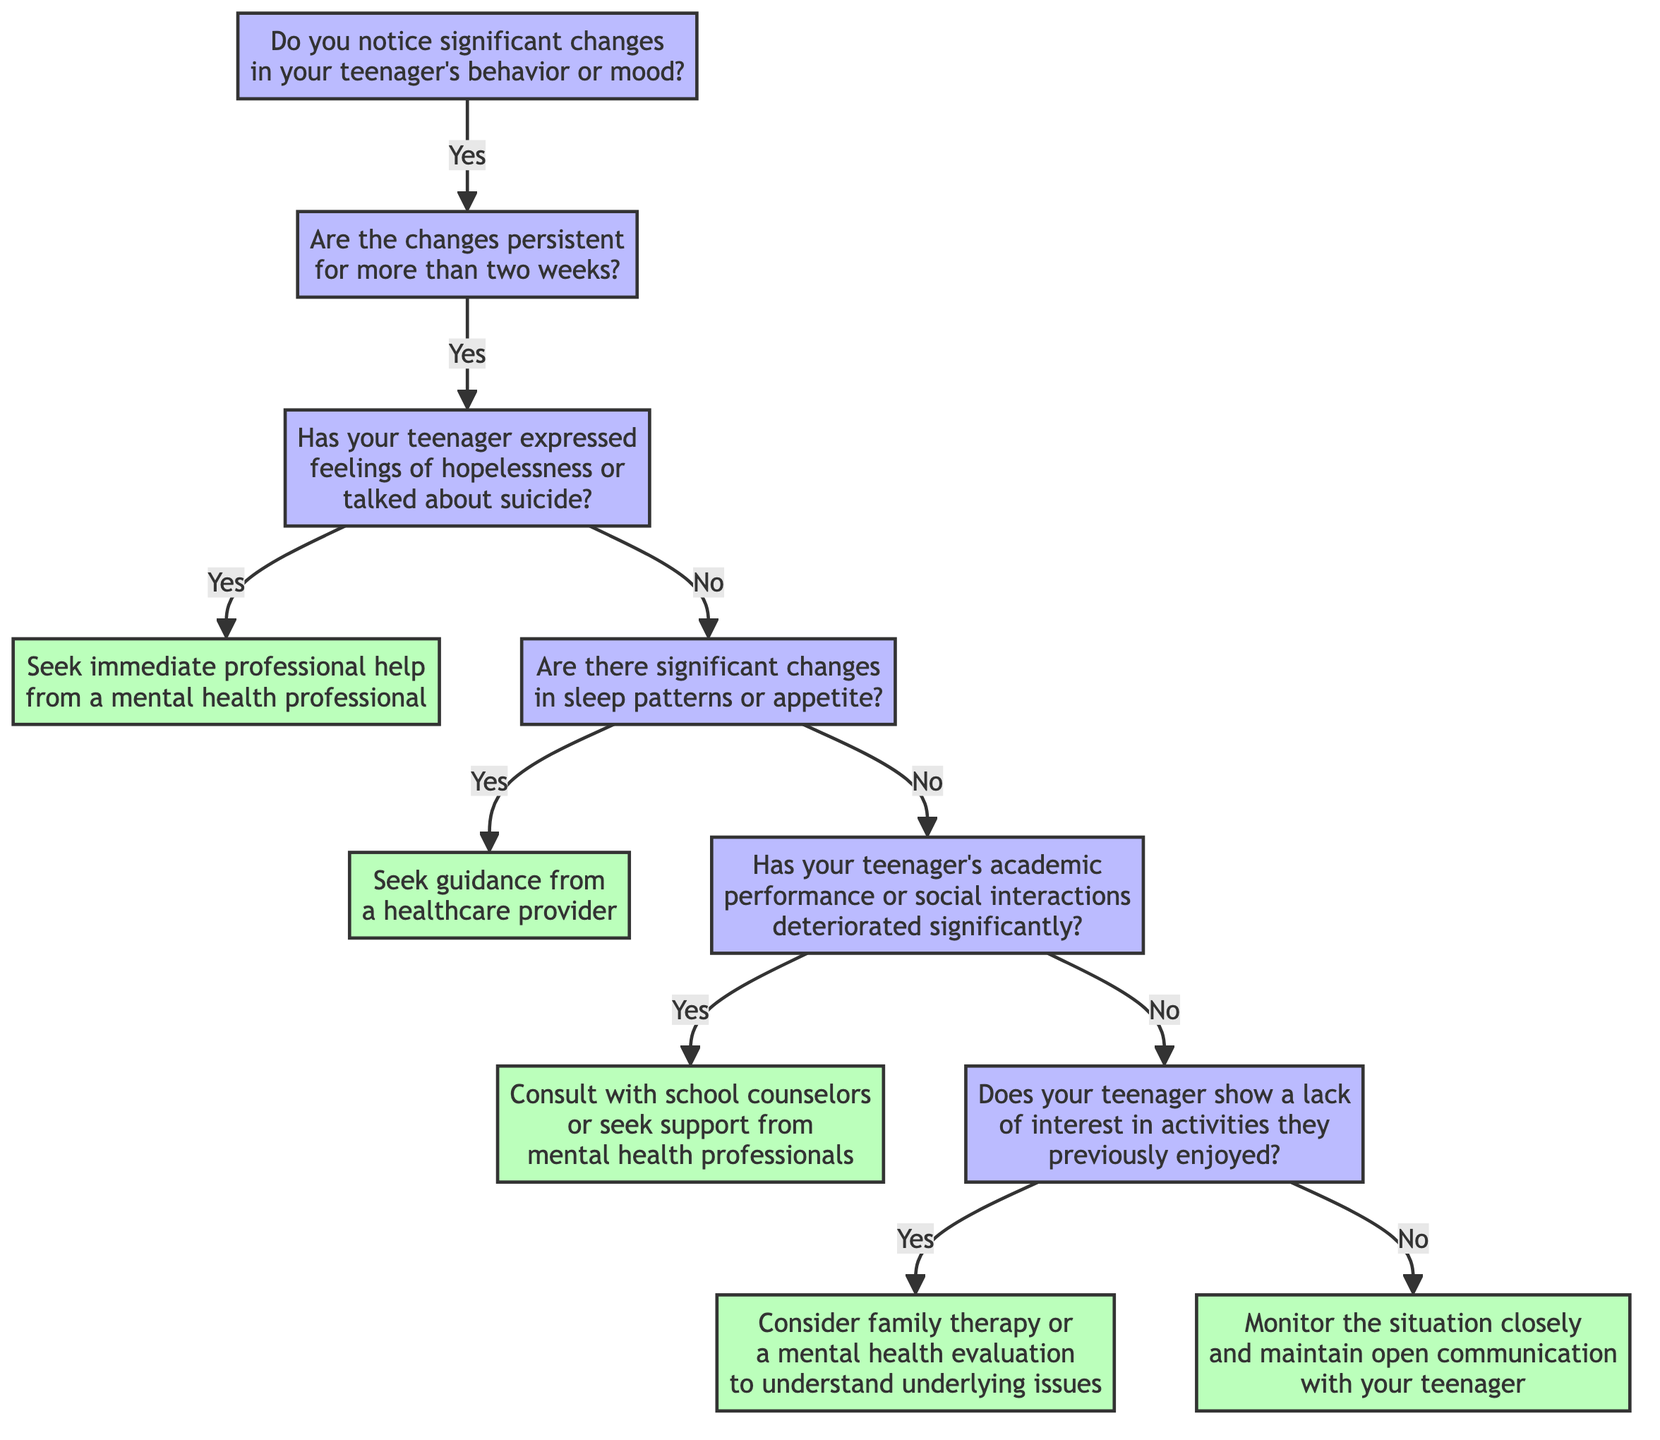What is the first question in the decision tree? The first question in the decision tree is posed at the start and asks whether there are significant changes in the teenager's behavior or mood. This sets the foundation for the subsequent decision points in the tree.
Answer: Do you notice significant changes in your teenager's behavior or mood? How many potential actions are presented in the tree? The decision tree presents five potential actions recommended at various nodes. These actions address different conditions related to mental health concerns and guide parents on what steps to take next.
Answer: Five What happens if a teenager expresses feelings of hopelessness? If a teenager expresses feelings of hopelessness or talks about suicide, the tree directs to seek immediate professional help from a mental health professional. This is a critical step indicating an urgent need for intervention.
Answer: Seek immediate professional help from a mental health professional If there are no changes in sleep patterns or appetite, what should be checked next? If there are no significant changes in sleep patterns or appetite, the next question to be considered is whether the teenager's academic performance or social interactions have deteriorated significantly. This continues the evaluation of the teenager's mental health.
Answer: Has your teenager's academic performance or social interactions deteriorated significantly? What is recommended if a teenager shows a lack of interest in previously enjoyed activities? If a teenager shows a lack of interest in activities they previously enjoyed, the recommendation is to consider family therapy or a mental health evaluation to understand any underlying issues they may be facing. This addresses the potential need for therapeutic intervention.
Answer: Consider family therapy or a mental health evaluation to understand underlying issues 